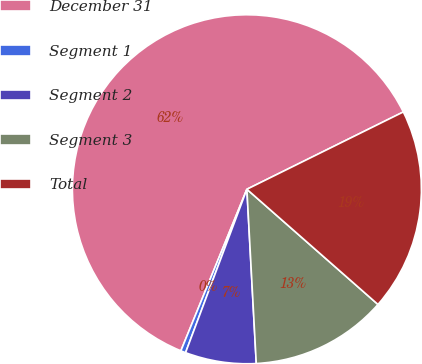Convert chart to OTSL. <chart><loc_0><loc_0><loc_500><loc_500><pie_chart><fcel>December 31<fcel>Segment 1<fcel>Segment 2<fcel>Segment 3<fcel>Total<nl><fcel>61.52%<fcel>0.46%<fcel>6.57%<fcel>12.67%<fcel>18.78%<nl></chart> 